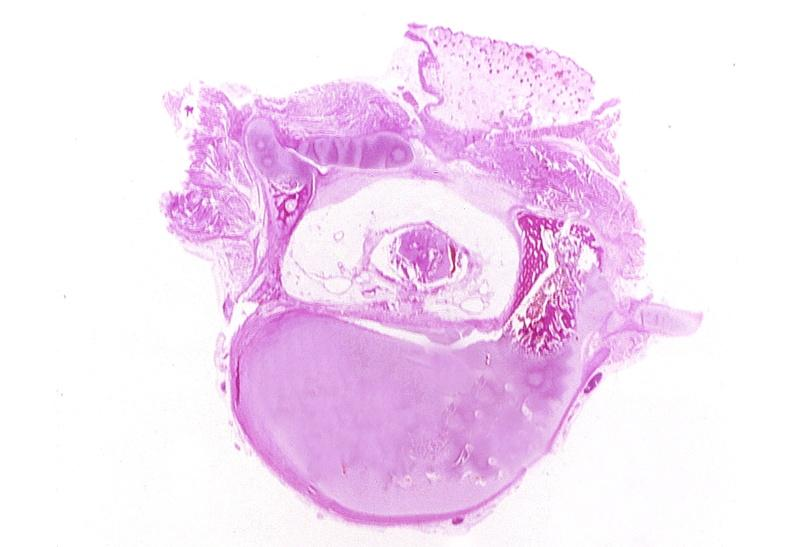s nervous present?
Answer the question using a single word or phrase. Yes 